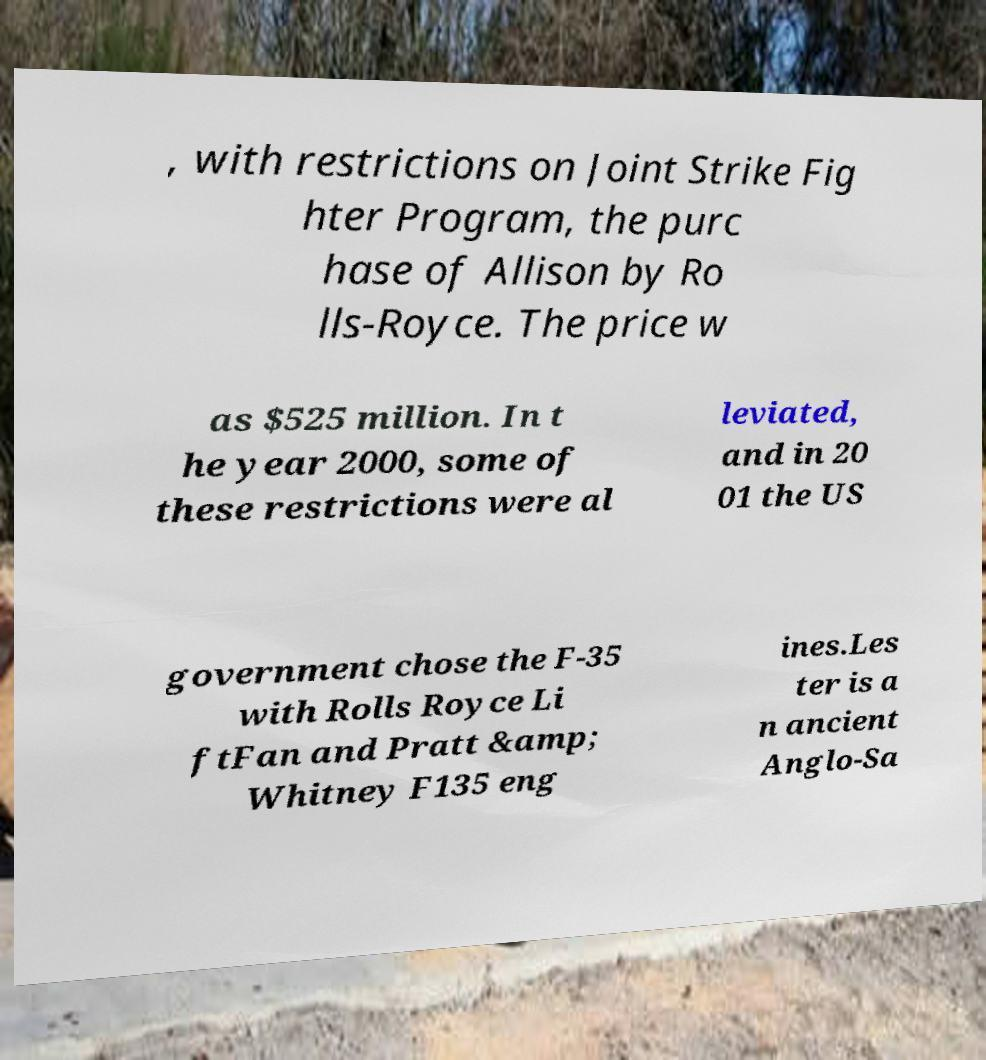Please identify and transcribe the text found in this image. , with restrictions on Joint Strike Fig hter Program, the purc hase of Allison by Ro lls-Royce. The price w as $525 million. In t he year 2000, some of these restrictions were al leviated, and in 20 01 the US government chose the F-35 with Rolls Royce Li ftFan and Pratt &amp; Whitney F135 eng ines.Les ter is a n ancient Anglo-Sa 